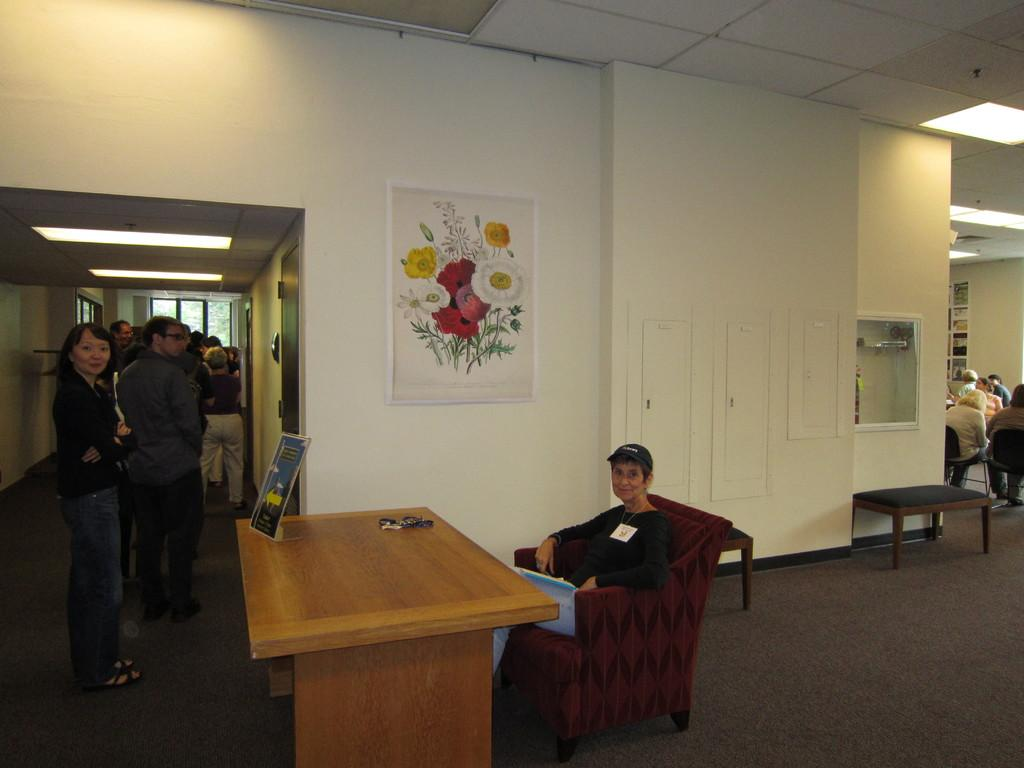What is the main subject of the image? The main subject of the image is a group of people. Can you describe the position of the woman in the image? The woman is seated on a chair in the image. What piece of furniture is present in the image? There is a table in the image. What can be seen on the wall in the image? There is a photo frame on the wall in the image. What type of river can be seen in the background of the image? There is no river visible in the image; it only features a group of people, a seated woman, a table, and a photo frame on the wall. 